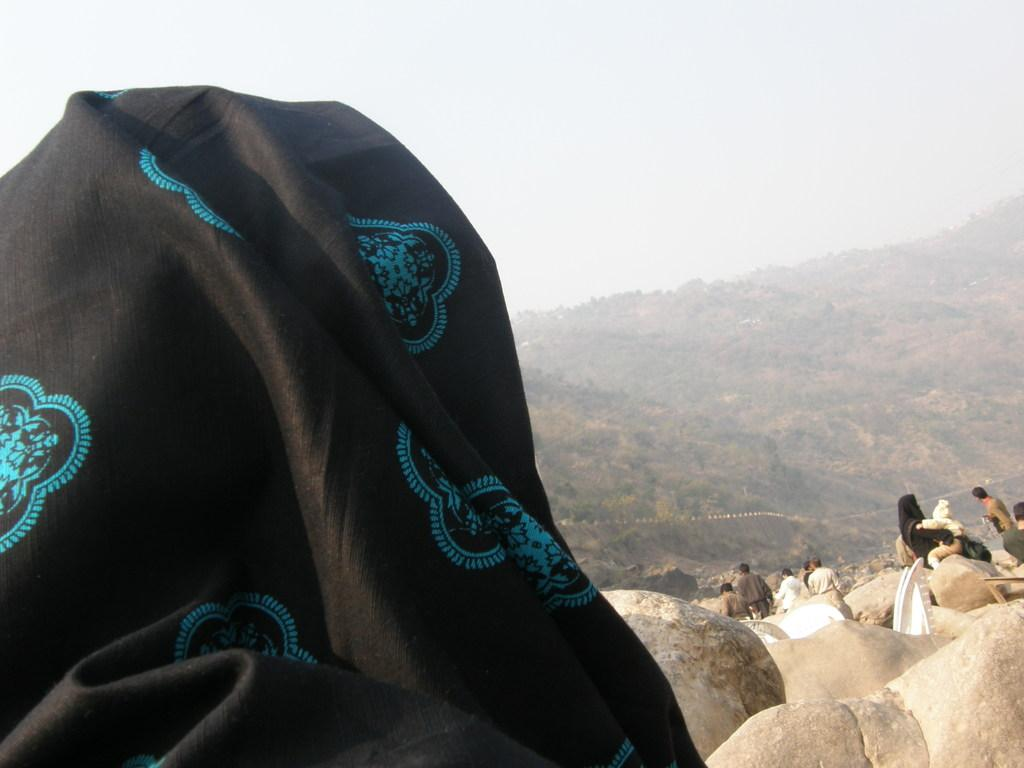What is the color of the cloth in the image? The cloth in the image is black. What is located in front of the black cloth? There are people and stones in front of the black cloth. What can be seen in the background of the image? Hills and the sky are visible in the background of the image. What type of produce is being harvested in the image? There is no produce or harvesting activity visible in the image. What territory is being claimed by the people in the image? The image does not depict any territorial claims or disputes. 